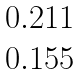Convert formula to latex. <formula><loc_0><loc_0><loc_500><loc_500>\begin{matrix} { 0 . 2 1 1 } \\ { 0 . 1 5 5 } \end{matrix}</formula> 